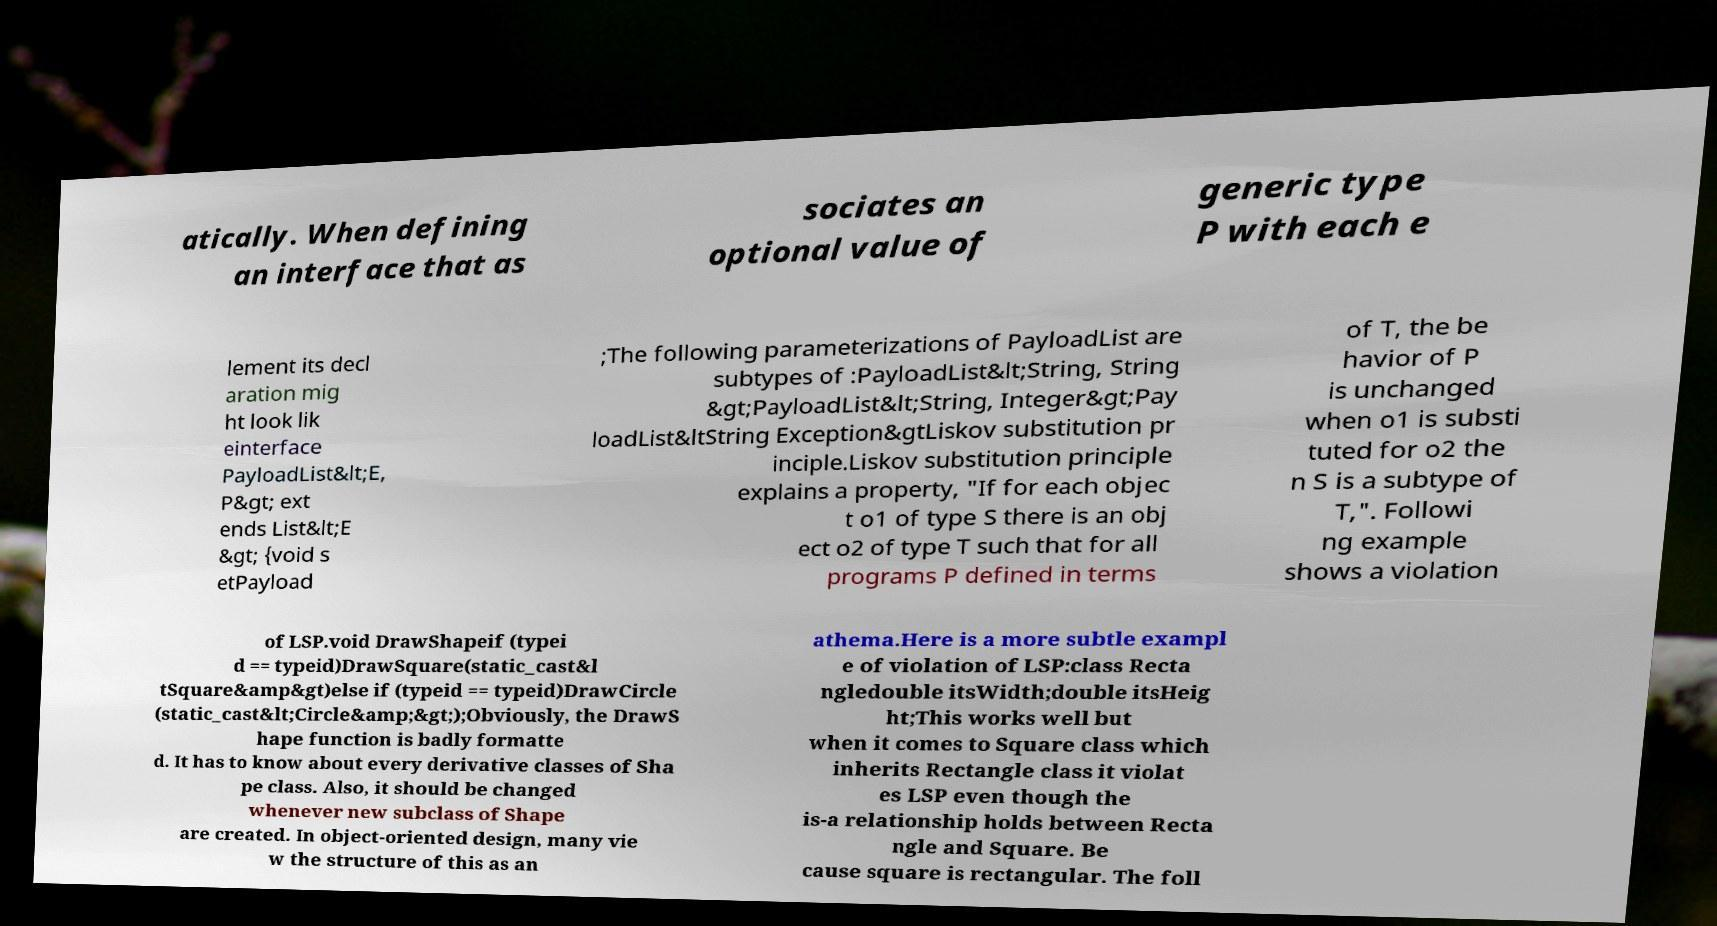Could you assist in decoding the text presented in this image and type it out clearly? atically. When defining an interface that as sociates an optional value of generic type P with each e lement its decl aration mig ht look lik einterface PayloadList&lt;E, P&gt; ext ends List&lt;E &gt; {void s etPayload ;The following parameterizations of PayloadList are subtypes of :PayloadList&lt;String, String &gt;PayloadList&lt;String, Integer&gt;Pay loadList&ltString Exception&gtLiskov substitution pr inciple.Liskov substitution principle explains a property, "If for each objec t o1 of type S there is an obj ect o2 of type T such that for all programs P defined in terms of T, the be havior of P is unchanged when o1 is substi tuted for o2 the n S is a subtype of T,". Followi ng example shows a violation of LSP.void DrawShapeif (typei d == typeid)DrawSquare(static_cast&l tSquare&amp&gt)else if (typeid == typeid)DrawCircle (static_cast&lt;Circle&amp;&gt;);Obviously, the DrawS hape function is badly formatte d. It has to know about every derivative classes of Sha pe class. Also, it should be changed whenever new subclass of Shape are created. In object-oriented design, many vie w the structure of this as an athema.Here is a more subtle exampl e of violation of LSP:class Recta ngledouble itsWidth;double itsHeig ht;This works well but when it comes to Square class which inherits Rectangle class it violat es LSP even though the is-a relationship holds between Recta ngle and Square. Be cause square is rectangular. The foll 